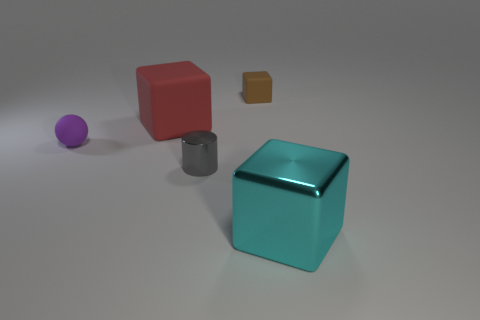Is there any other thing that has the same shape as the tiny purple thing?
Your answer should be very brief. No. How big is the red rubber block?
Make the answer very short. Large. The large object to the left of the small gray thing has what shape?
Your answer should be very brief. Cube. Is the brown object the same shape as the large metal object?
Keep it short and to the point. Yes. Are there the same number of tiny brown rubber objects that are left of the rubber sphere and large red cubes?
Provide a succinct answer. No. What is the shape of the red matte thing?
Give a very brief answer. Cube. There is a metal object that is to the left of the big metallic object; is it the same size as the rubber object that is to the right of the cylinder?
Make the answer very short. Yes. What shape is the big thing on the left side of the tiny matte object right of the purple matte sphere?
Your answer should be very brief. Cube. There is a brown block; is it the same size as the metal thing to the left of the tiny brown cube?
Your response must be concise. Yes. There is a shiny object that is in front of the cylinder that is right of the big cube that is behind the large cyan cube; what is its size?
Make the answer very short. Large. 